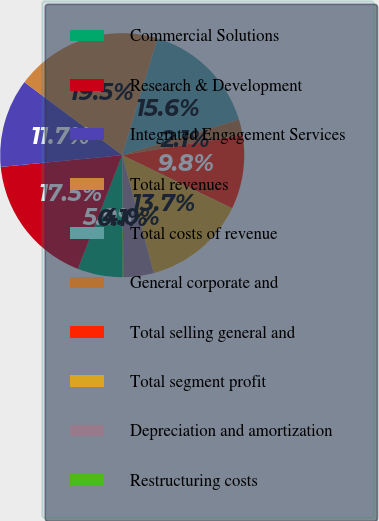Convert chart. <chart><loc_0><loc_0><loc_500><loc_500><pie_chart><fcel>Commercial Solutions<fcel>Research & Development<fcel>Integrated Engagement Services<fcel>Total revenues<fcel>Total costs of revenue<fcel>General corporate and<fcel>Total selling general and<fcel>Total segment profit<fcel>Depreciation and amortization<fcel>Restructuring costs<nl><fcel>5.94%<fcel>17.54%<fcel>11.74%<fcel>19.48%<fcel>15.61%<fcel>2.07%<fcel>9.81%<fcel>13.68%<fcel>4.0%<fcel>0.14%<nl></chart> 